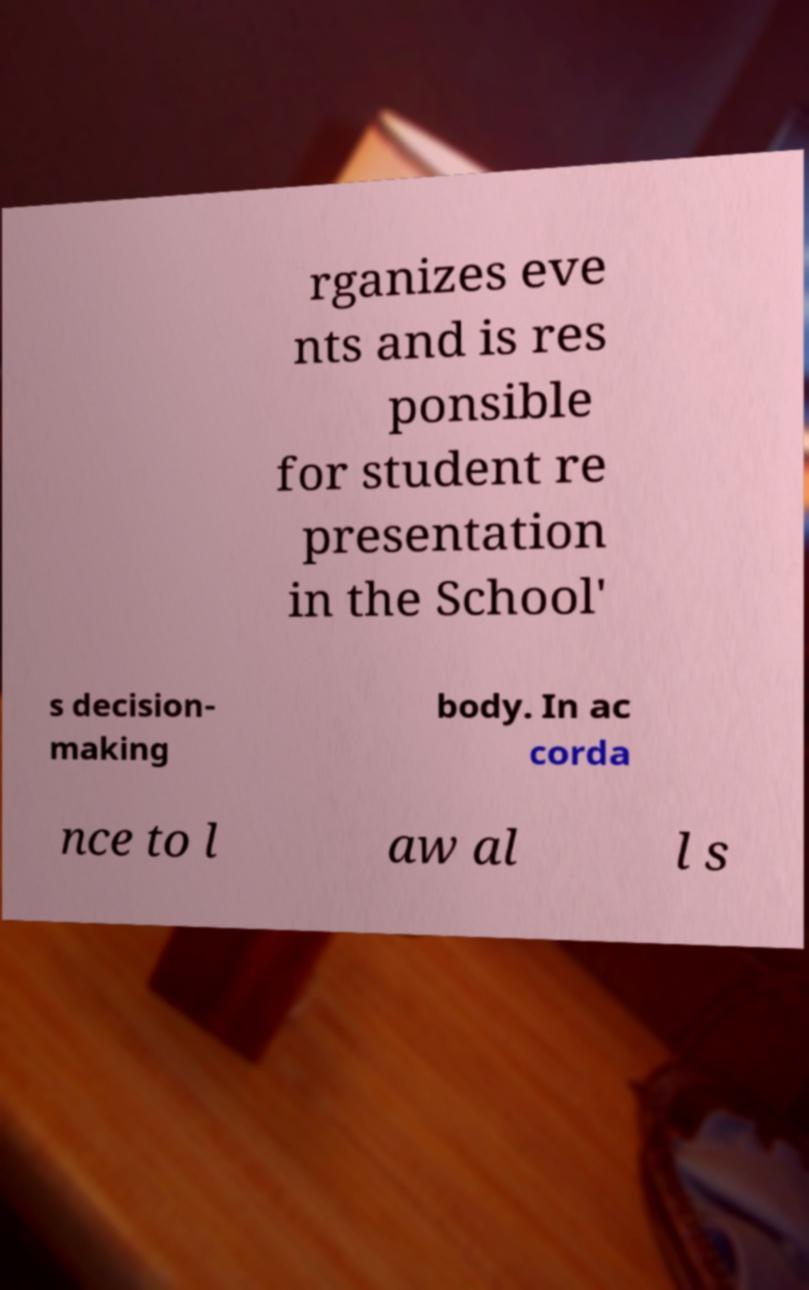I need the written content from this picture converted into text. Can you do that? rganizes eve nts and is res ponsible for student re presentation in the School' s decision- making body. In ac corda nce to l aw al l s 